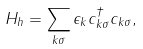<formula> <loc_0><loc_0><loc_500><loc_500>H _ { h } = \sum _ { k \sigma } \epsilon _ { k } c _ { k \sigma } ^ { \dagger } c _ { k \sigma } ,</formula> 